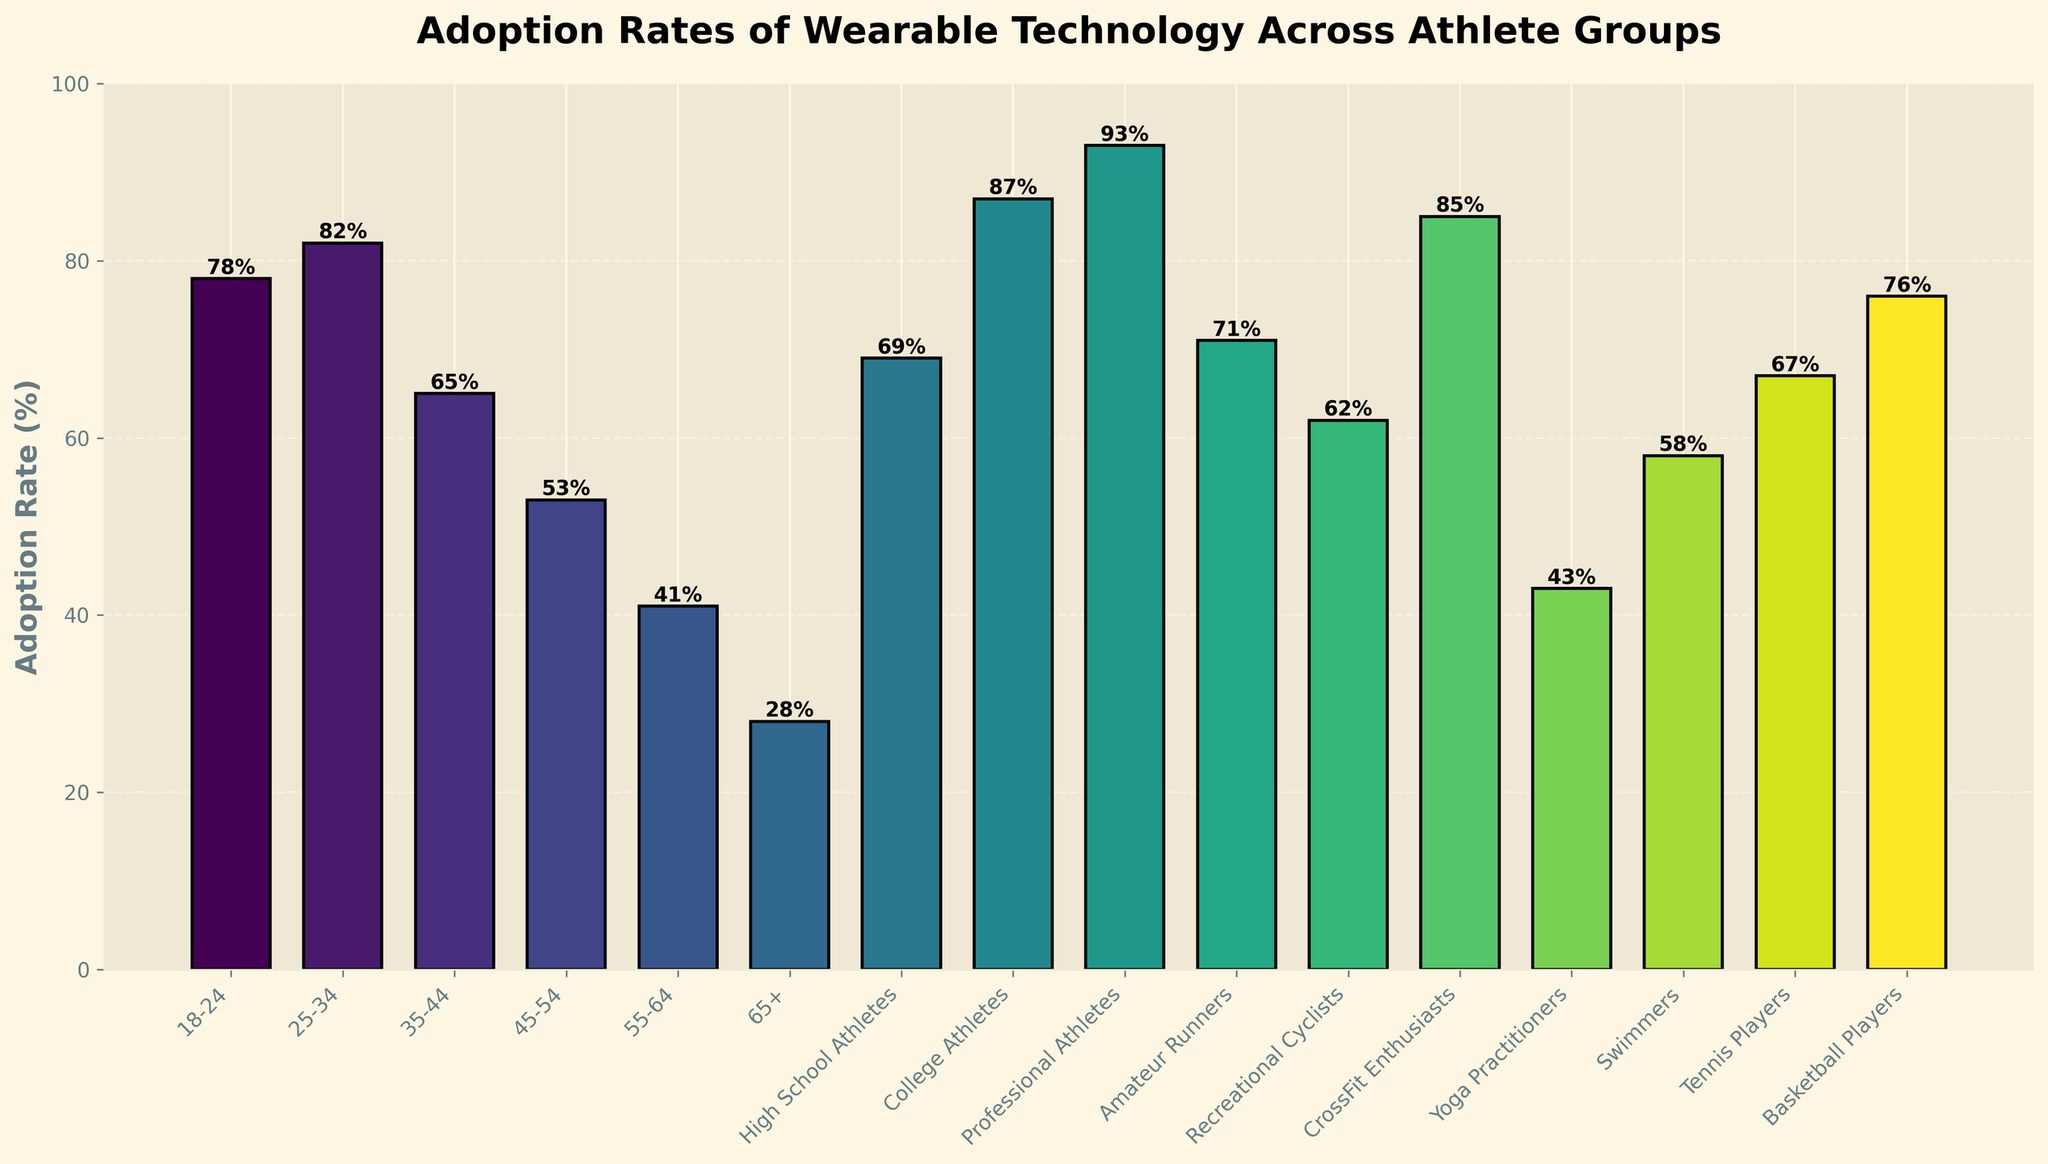Which age group has the highest adoption rate of wearable technology? The highest bar on the figure corresponds to the age group 25-34, which reaches an adoption rate of 82%.
Answer: 25-34 What is the average adoption rate of wearable technology among all age groups? First, list out the adoption rates for each age group (78, 82, 65, 53, 41, 28). Calculate the sum of these values: 78 + 82 + 65 + 53 + 41 + 28 = 347. Then, divide this sum by the number of age groups, which is 6: 347 / 6 ≈ 57.83%.
Answer: 57.83% Which athlete group has the lowest adoption rate of wearable technology? By examining the height of the bars representing athlete groups, it is clear that the "65+" group has the lowest adoption rate at 28%.
Answer: 65+ How much higher is the adoption rate for college athletes compared to high school athletes? The adoption rate for college athletes is 87%, and for high school athletes, it is 69%. The difference is calculated by subtracting the adoption rate of high school athletes from that of college athletes: 87% - 69% = 18%.
Answer: 18% Which sport has a higher adoption rate: Tennis or Basketball? By comparing the heights of the bars for Tennis Players (67%) and Basketball Players (76%), it is evident that Basketball Players have a higher adoption rate.
Answer: Basketball What is the average adoption rate for professional athletes, crossfit enthusiasts, and swimmers? List the adoption rates for these groups: Professional Athletes (93%), CrossFit Enthusiasts (85%), Swimmers (58%). Sum them up: 93 + 85 + 58 = 236. Divide by the number of groups, which is 3: 236 / 3 ≈ 78.67%.
Answer: 78.67% Which group has a higher adoption rate: Amateur Runners or Yoga Practitioners? Comparing the bars for Amateur Runners (71%) and Yoga Practitioners (43%), Amateur Runners have a higher adoption rate.
Answer: Amateur Runners Which two age groups have the closest adoption rates? By closely comparing the heights of the bars for different age groups, the age groups 18-24 (78%) and 25-34 (82%) are nearest in adoption rates, with a difference of 4%.
Answer: 18-24 and 25-34 How does the adoption rate for Recreational Cyclists compare to that of Swimmers? The bar for Recreational Cyclists shows an adoption rate of 62%, while the bar for Swimmers shows 58%. Hence, Recreational Cyclists have a 4% higher adoption rate compared to Swimmers.
Answer: 4% What is the median adoption rate of wearable technology among all the age groups? List all the adoption rates for the age groups (78, 82, 65, 53, 41, 28) in ascending order: 28, 41, 53, 65, 78, 82. With an even number of values, the median will be the average of the two middle values: (53 + 65) / 2 = 59%.
Answer: 59% 